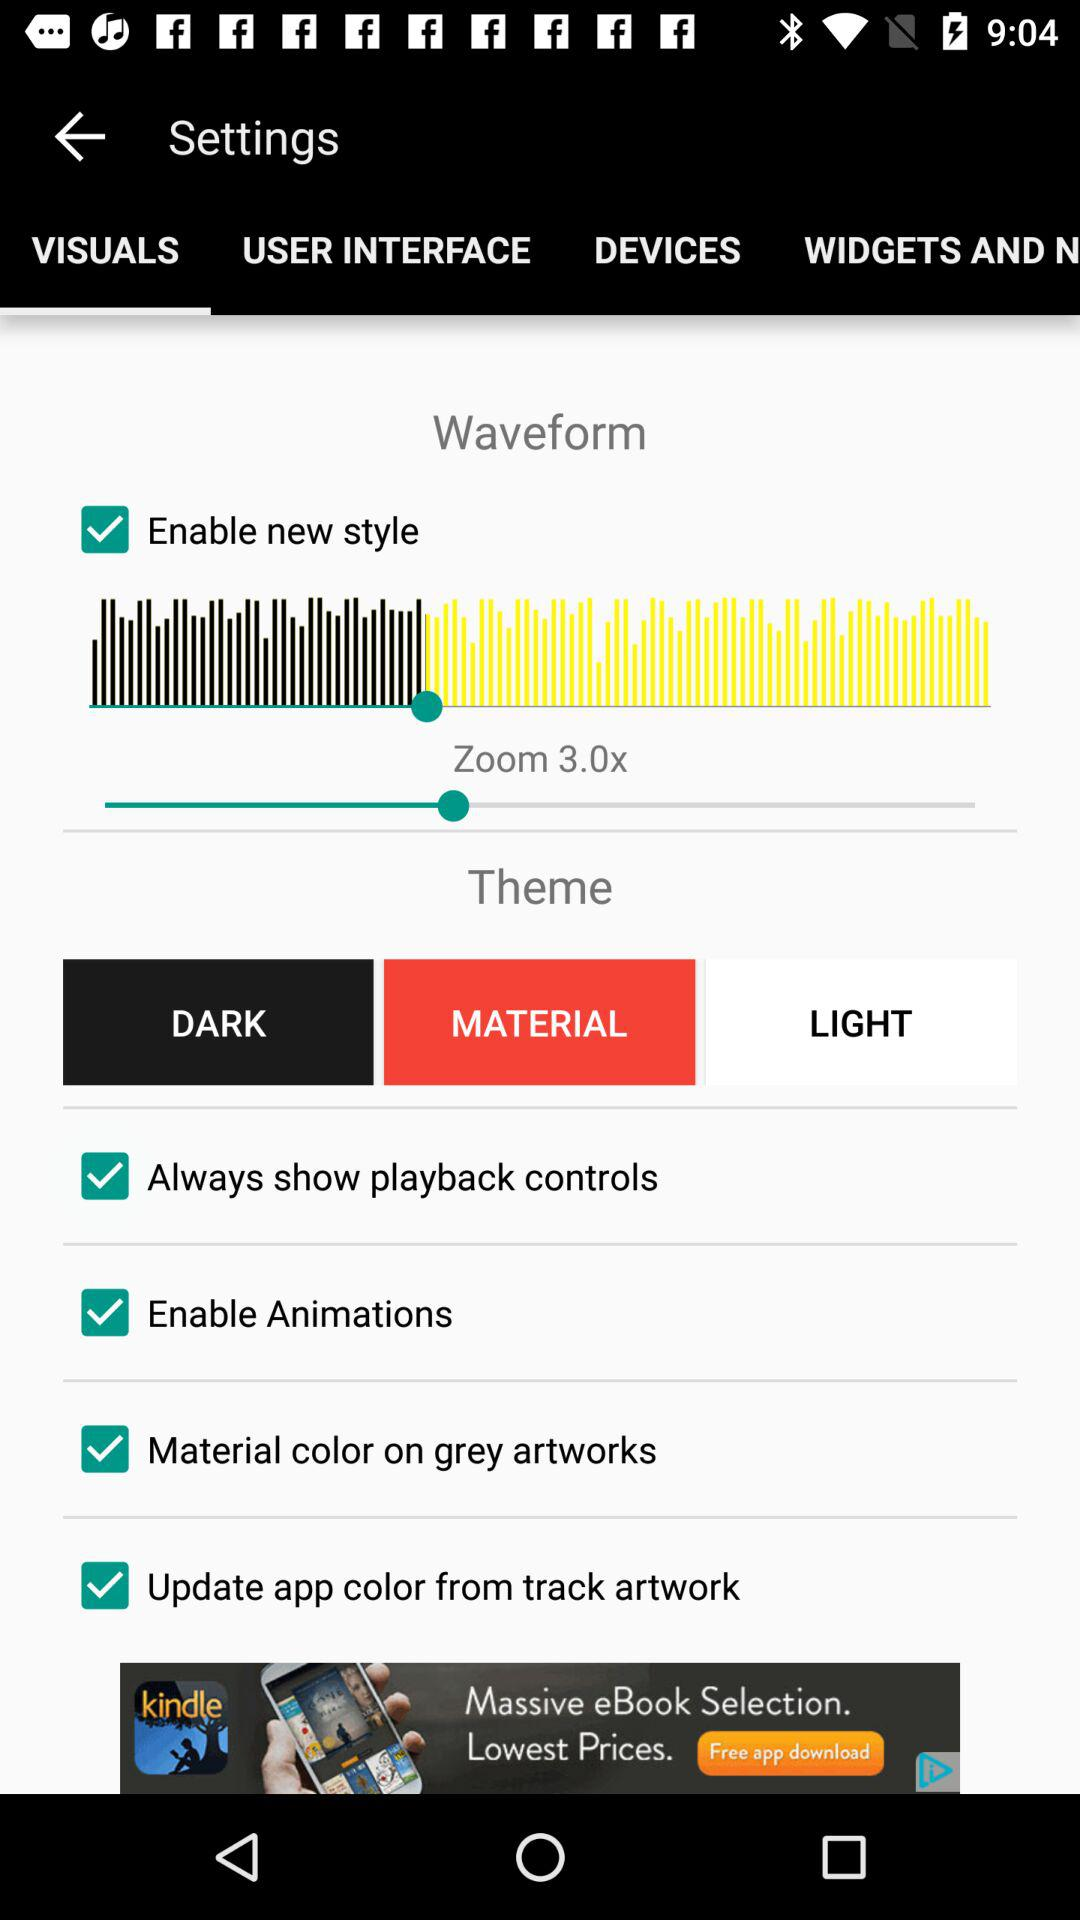How many notifications are there in "DEVICES"?
When the provided information is insufficient, respond with <no answer>. <no answer> 